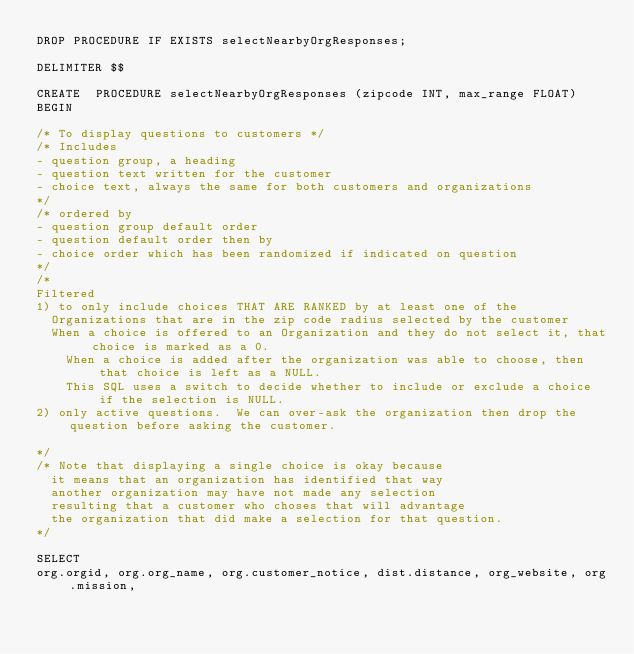<code> <loc_0><loc_0><loc_500><loc_500><_SQL_>DROP PROCEDURE IF EXISTS selectNearbyOrgResponses;

DELIMITER $$

CREATE  PROCEDURE selectNearbyOrgResponses (zipcode INT, max_range FLOAT)
BEGIN
  
/* To display questions to customers */
/* Includes
-	question group, a heading
-	question text written for the customer
-	choice text, always the same for both customers and organizations
*/
/* ordered by
-	question group default order
-	question default order then by
-	choice order which has been randomized if indicated on question
*/
/*
Filtered 
1) to only include choices THAT ARE RANKED by at least one of the 
	Organizations that are in the zip code radius selected by the customer
	When a choice is offered to an Organization and they do not select it, that choice is marked as a 0.
    When a choice is added after the organization was able to choose, then that choice is left as a NULL.
    This SQL uses a switch to decide whether to include or exclude a choice if the selection is NULL.
2) only active questions.  We can over-ask the organization then drop the question before asking the customer.

*/
/* Note that displaying a single choice is okay because
	it means that an organization has identified that way
	another organization may have not made any selection
	resulting that a customer who choses that will advantage
	the organization that did make a selection for that question.
*/

SELECT 
org.orgid, org.org_name, org.customer_notice, dist.distance, org_website, org.mission, </code> 